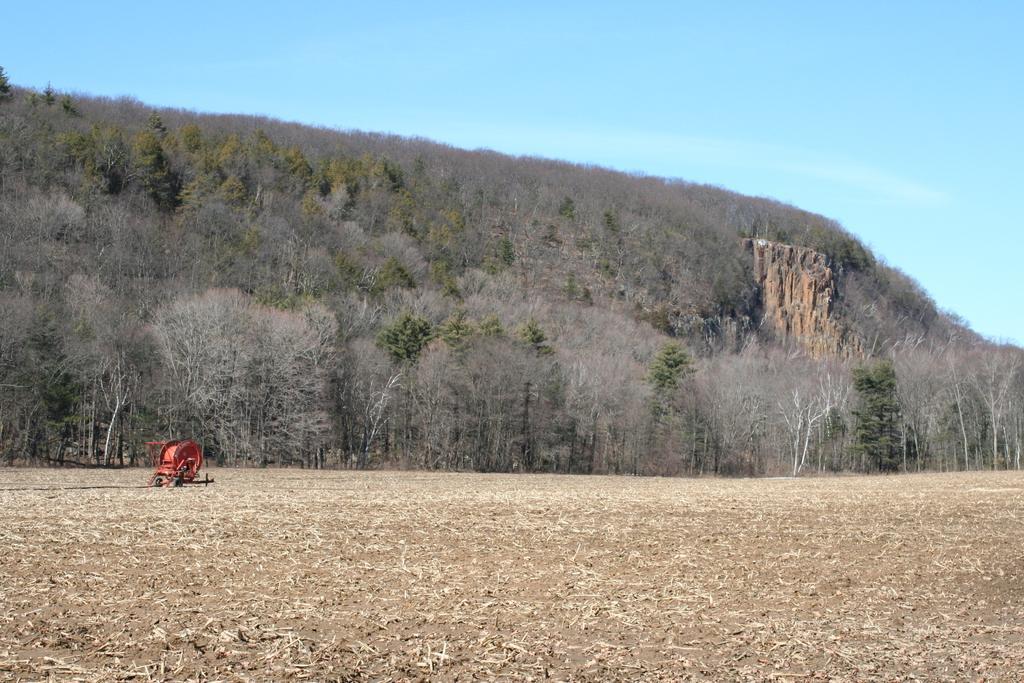Describe this image in one or two sentences. In this image we can see a red color object on the ground. And there are trees, rock and sky in the background. 